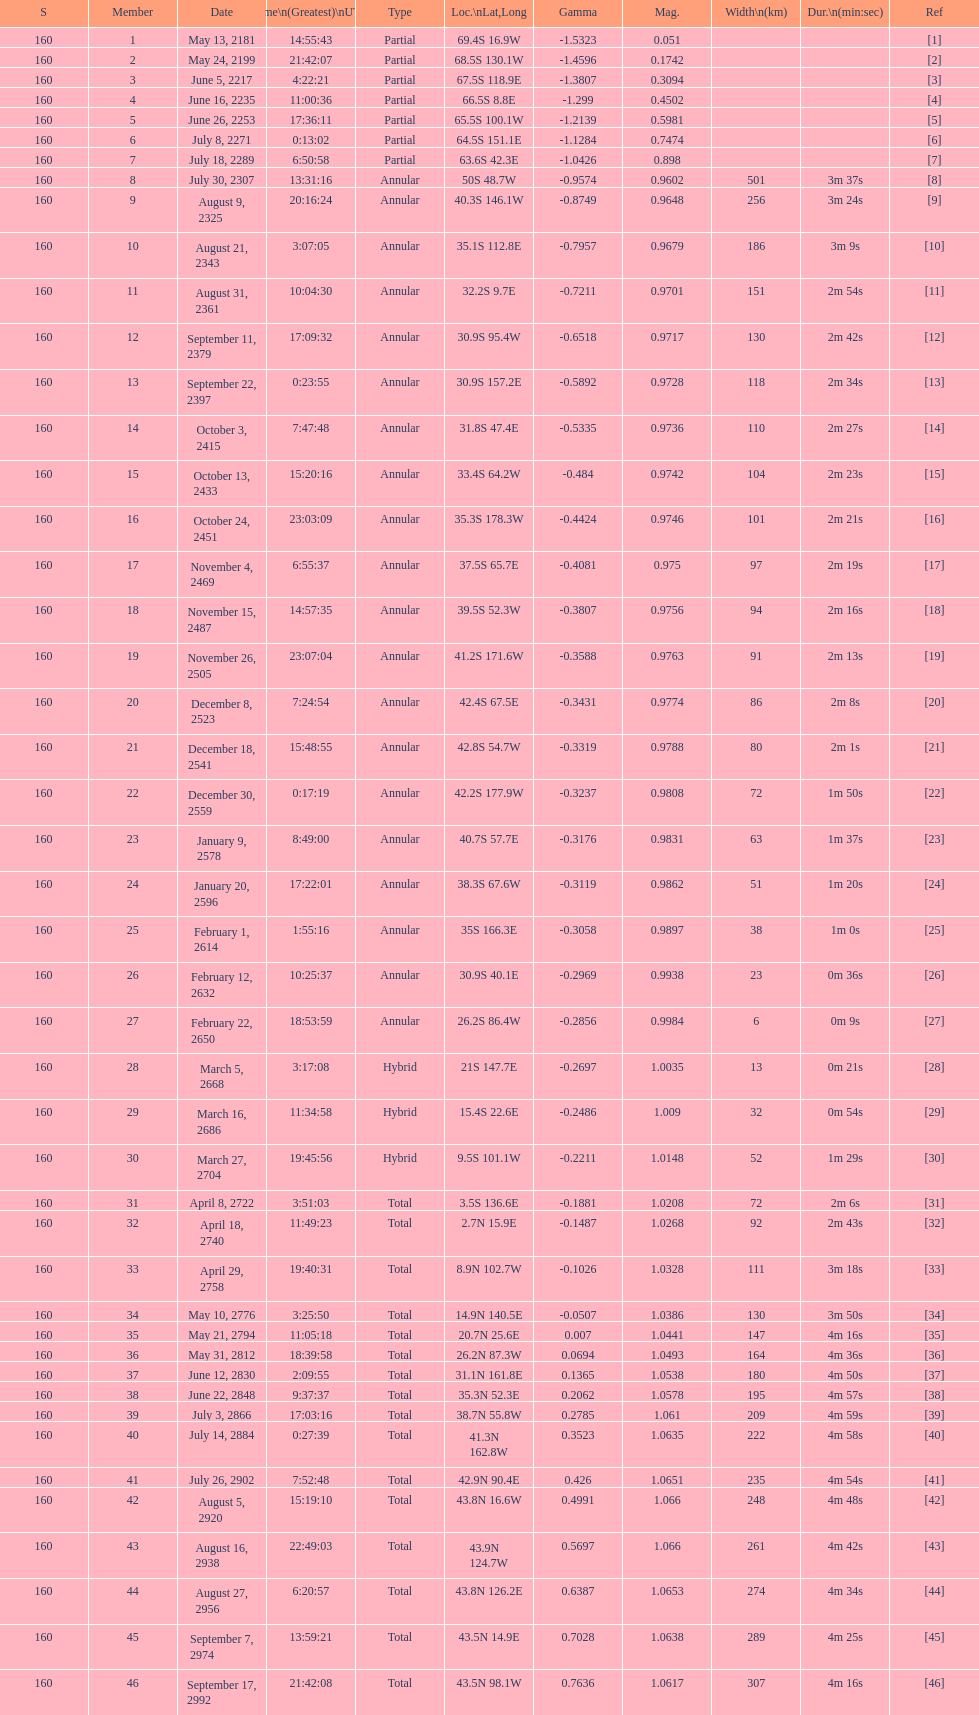When did the first solar saros with a magnitude of greater than 1.00 occur? March 5, 2668. I'm looking to parse the entire table for insights. Could you assist me with that? {'header': ['S', 'Member', 'Date', 'Time\\n(Greatest)\\nUTC', 'Type', 'Loc.\\nLat,Long', 'Gamma', 'Mag.', 'Width\\n(km)', 'Dur.\\n(min:sec)', 'Ref'], 'rows': [['160', '1', 'May 13, 2181', '14:55:43', 'Partial', '69.4S 16.9W', '-1.5323', '0.051', '', '', '[1]'], ['160', '2', 'May 24, 2199', '21:42:07', 'Partial', '68.5S 130.1W', '-1.4596', '0.1742', '', '', '[2]'], ['160', '3', 'June 5, 2217', '4:22:21', 'Partial', '67.5S 118.9E', '-1.3807', '0.3094', '', '', '[3]'], ['160', '4', 'June 16, 2235', '11:00:36', 'Partial', '66.5S 8.8E', '-1.299', '0.4502', '', '', '[4]'], ['160', '5', 'June 26, 2253', '17:36:11', 'Partial', '65.5S 100.1W', '-1.2139', '0.5981', '', '', '[5]'], ['160', '6', 'July 8, 2271', '0:13:02', 'Partial', '64.5S 151.1E', '-1.1284', '0.7474', '', '', '[6]'], ['160', '7', 'July 18, 2289', '6:50:58', 'Partial', '63.6S 42.3E', '-1.0426', '0.898', '', '', '[7]'], ['160', '8', 'July 30, 2307', '13:31:16', 'Annular', '50S 48.7W', '-0.9574', '0.9602', '501', '3m 37s', '[8]'], ['160', '9', 'August 9, 2325', '20:16:24', 'Annular', '40.3S 146.1W', '-0.8749', '0.9648', '256', '3m 24s', '[9]'], ['160', '10', 'August 21, 2343', '3:07:05', 'Annular', '35.1S 112.8E', '-0.7957', '0.9679', '186', '3m 9s', '[10]'], ['160', '11', 'August 31, 2361', '10:04:30', 'Annular', '32.2S 9.7E', '-0.7211', '0.9701', '151', '2m 54s', '[11]'], ['160', '12', 'September 11, 2379', '17:09:32', 'Annular', '30.9S 95.4W', '-0.6518', '0.9717', '130', '2m 42s', '[12]'], ['160', '13', 'September 22, 2397', '0:23:55', 'Annular', '30.9S 157.2E', '-0.5892', '0.9728', '118', '2m 34s', '[13]'], ['160', '14', 'October 3, 2415', '7:47:48', 'Annular', '31.8S 47.4E', '-0.5335', '0.9736', '110', '2m 27s', '[14]'], ['160', '15', 'October 13, 2433', '15:20:16', 'Annular', '33.4S 64.2W', '-0.484', '0.9742', '104', '2m 23s', '[15]'], ['160', '16', 'October 24, 2451', '23:03:09', 'Annular', '35.3S 178.3W', '-0.4424', '0.9746', '101', '2m 21s', '[16]'], ['160', '17', 'November 4, 2469', '6:55:37', 'Annular', '37.5S 65.7E', '-0.4081', '0.975', '97', '2m 19s', '[17]'], ['160', '18', 'November 15, 2487', '14:57:35', 'Annular', '39.5S 52.3W', '-0.3807', '0.9756', '94', '2m 16s', '[18]'], ['160', '19', 'November 26, 2505', '23:07:04', 'Annular', '41.2S 171.6W', '-0.3588', '0.9763', '91', '2m 13s', '[19]'], ['160', '20', 'December 8, 2523', '7:24:54', 'Annular', '42.4S 67.5E', '-0.3431', '0.9774', '86', '2m 8s', '[20]'], ['160', '21', 'December 18, 2541', '15:48:55', 'Annular', '42.8S 54.7W', '-0.3319', '0.9788', '80', '2m 1s', '[21]'], ['160', '22', 'December 30, 2559', '0:17:19', 'Annular', '42.2S 177.9W', '-0.3237', '0.9808', '72', '1m 50s', '[22]'], ['160', '23', 'January 9, 2578', '8:49:00', 'Annular', '40.7S 57.7E', '-0.3176', '0.9831', '63', '1m 37s', '[23]'], ['160', '24', 'January 20, 2596', '17:22:01', 'Annular', '38.3S 67.6W', '-0.3119', '0.9862', '51', '1m 20s', '[24]'], ['160', '25', 'February 1, 2614', '1:55:16', 'Annular', '35S 166.3E', '-0.3058', '0.9897', '38', '1m 0s', '[25]'], ['160', '26', 'February 12, 2632', '10:25:37', 'Annular', '30.9S 40.1E', '-0.2969', '0.9938', '23', '0m 36s', '[26]'], ['160', '27', 'February 22, 2650', '18:53:59', 'Annular', '26.2S 86.4W', '-0.2856', '0.9984', '6', '0m 9s', '[27]'], ['160', '28', 'March 5, 2668', '3:17:08', 'Hybrid', '21S 147.7E', '-0.2697', '1.0035', '13', '0m 21s', '[28]'], ['160', '29', 'March 16, 2686', '11:34:58', 'Hybrid', '15.4S 22.6E', '-0.2486', '1.009', '32', '0m 54s', '[29]'], ['160', '30', 'March 27, 2704', '19:45:56', 'Hybrid', '9.5S 101.1W', '-0.2211', '1.0148', '52', '1m 29s', '[30]'], ['160', '31', 'April 8, 2722', '3:51:03', 'Total', '3.5S 136.6E', '-0.1881', '1.0208', '72', '2m 6s', '[31]'], ['160', '32', 'April 18, 2740', '11:49:23', 'Total', '2.7N 15.9E', '-0.1487', '1.0268', '92', '2m 43s', '[32]'], ['160', '33', 'April 29, 2758', '19:40:31', 'Total', '8.9N 102.7W', '-0.1026', '1.0328', '111', '3m 18s', '[33]'], ['160', '34', 'May 10, 2776', '3:25:50', 'Total', '14.9N 140.5E', '-0.0507', '1.0386', '130', '3m 50s', '[34]'], ['160', '35', 'May 21, 2794', '11:05:18', 'Total', '20.7N 25.6E', '0.007', '1.0441', '147', '4m 16s', '[35]'], ['160', '36', 'May 31, 2812', '18:39:58', 'Total', '26.2N 87.3W', '0.0694', '1.0493', '164', '4m 36s', '[36]'], ['160', '37', 'June 12, 2830', '2:09:55', 'Total', '31.1N 161.8E', '0.1365', '1.0538', '180', '4m 50s', '[37]'], ['160', '38', 'June 22, 2848', '9:37:37', 'Total', '35.3N 52.3E', '0.2062', '1.0578', '195', '4m 57s', '[38]'], ['160', '39', 'July 3, 2866', '17:03:16', 'Total', '38.7N 55.8W', '0.2785', '1.061', '209', '4m 59s', '[39]'], ['160', '40', 'July 14, 2884', '0:27:39', 'Total', '41.3N 162.8W', '0.3523', '1.0635', '222', '4m 58s', '[40]'], ['160', '41', 'July 26, 2902', '7:52:48', 'Total', '42.9N 90.4E', '0.426', '1.0651', '235', '4m 54s', '[41]'], ['160', '42', 'August 5, 2920', '15:19:10', 'Total', '43.8N 16.6W', '0.4991', '1.066', '248', '4m 48s', '[42]'], ['160', '43', 'August 16, 2938', '22:49:03', 'Total', '43.9N 124.7W', '0.5697', '1.066', '261', '4m 42s', '[43]'], ['160', '44', 'August 27, 2956', '6:20:57', 'Total', '43.8N 126.2E', '0.6387', '1.0653', '274', '4m 34s', '[44]'], ['160', '45', 'September 7, 2974', '13:59:21', 'Total', '43.5N 14.9E', '0.7028', '1.0638', '289', '4m 25s', '[45]'], ['160', '46', 'September 17, 2992', '21:42:08', 'Total', '43.5N 98.1W', '0.7636', '1.0617', '307', '4m 16s', '[46]']]} 